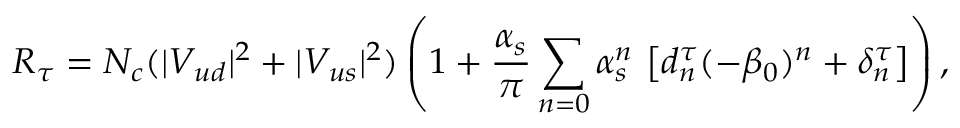Convert formula to latex. <formula><loc_0><loc_0><loc_500><loc_500>R _ { \tau } = N _ { c } ( | V _ { u d } | ^ { 2 } + | V _ { u s } | ^ { 2 } ) \left ( 1 + \frac { \alpha _ { s } } { \pi } \sum _ { n = 0 } \alpha _ { s } ^ { n } \, \left [ d _ { n } ^ { \tau } ( - \beta _ { 0 } ) ^ { n } + \delta _ { n } ^ { \tau } \right ] \right ) ,</formula> 